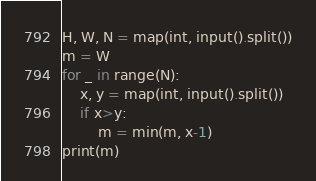Convert code to text. <code><loc_0><loc_0><loc_500><loc_500><_Python_>H, W, N = map(int, input().split())
m = W
for _ in range(N):
    x, y = map(int, input().split())
    if x>y:
        m = min(m, x-1)
print(m)



</code> 